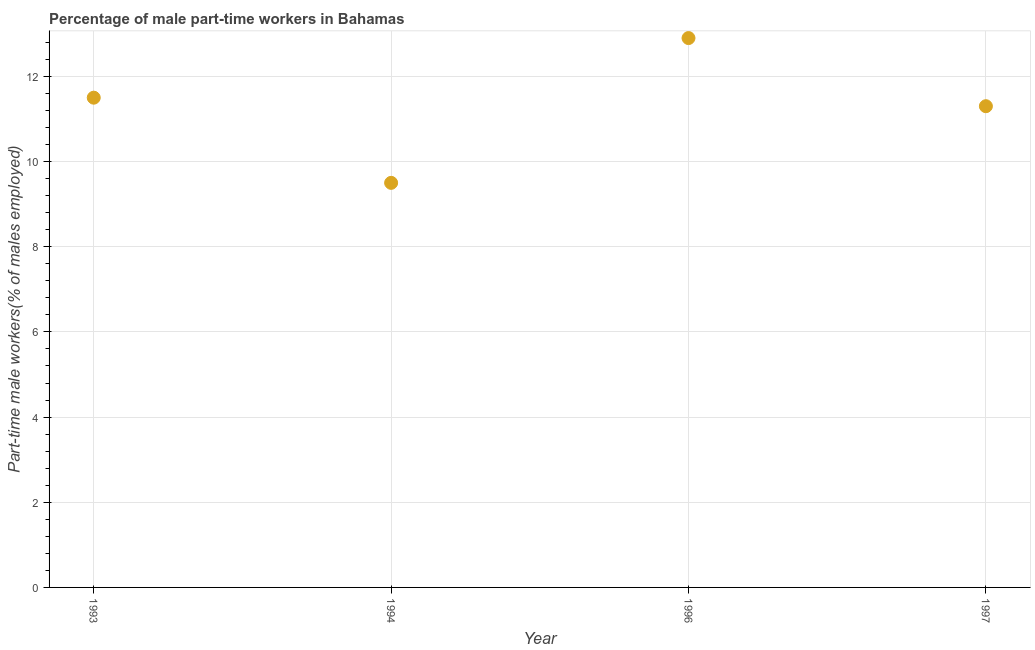What is the percentage of part-time male workers in 1993?
Your answer should be compact. 11.5. Across all years, what is the maximum percentage of part-time male workers?
Offer a terse response. 12.9. In which year was the percentage of part-time male workers maximum?
Keep it short and to the point. 1996. In which year was the percentage of part-time male workers minimum?
Offer a very short reply. 1994. What is the sum of the percentage of part-time male workers?
Your response must be concise. 45.2. What is the difference between the percentage of part-time male workers in 1993 and 1994?
Provide a succinct answer. 2. What is the average percentage of part-time male workers per year?
Your answer should be compact. 11.3. What is the median percentage of part-time male workers?
Ensure brevity in your answer.  11.4. In how many years, is the percentage of part-time male workers greater than 1.6 %?
Give a very brief answer. 4. What is the ratio of the percentage of part-time male workers in 1994 to that in 1997?
Offer a very short reply. 0.84. Is the percentage of part-time male workers in 1993 less than that in 1994?
Your response must be concise. No. Is the difference between the percentage of part-time male workers in 1993 and 1996 greater than the difference between any two years?
Your answer should be compact. No. What is the difference between the highest and the second highest percentage of part-time male workers?
Offer a terse response. 1.4. What is the difference between the highest and the lowest percentage of part-time male workers?
Provide a succinct answer. 3.4. Does the percentage of part-time male workers monotonically increase over the years?
Provide a short and direct response. No. Does the graph contain any zero values?
Your response must be concise. No. Does the graph contain grids?
Keep it short and to the point. Yes. What is the title of the graph?
Your answer should be compact. Percentage of male part-time workers in Bahamas. What is the label or title of the X-axis?
Offer a terse response. Year. What is the label or title of the Y-axis?
Your answer should be compact. Part-time male workers(% of males employed). What is the Part-time male workers(% of males employed) in 1993?
Offer a very short reply. 11.5. What is the Part-time male workers(% of males employed) in 1996?
Offer a very short reply. 12.9. What is the Part-time male workers(% of males employed) in 1997?
Your response must be concise. 11.3. What is the difference between the Part-time male workers(% of males employed) in 1993 and 1996?
Provide a short and direct response. -1.4. What is the difference between the Part-time male workers(% of males employed) in 1993 and 1997?
Keep it short and to the point. 0.2. What is the difference between the Part-time male workers(% of males employed) in 1994 and 1996?
Keep it short and to the point. -3.4. What is the ratio of the Part-time male workers(% of males employed) in 1993 to that in 1994?
Ensure brevity in your answer.  1.21. What is the ratio of the Part-time male workers(% of males employed) in 1993 to that in 1996?
Ensure brevity in your answer.  0.89. What is the ratio of the Part-time male workers(% of males employed) in 1994 to that in 1996?
Give a very brief answer. 0.74. What is the ratio of the Part-time male workers(% of males employed) in 1994 to that in 1997?
Your answer should be compact. 0.84. What is the ratio of the Part-time male workers(% of males employed) in 1996 to that in 1997?
Ensure brevity in your answer.  1.14. 